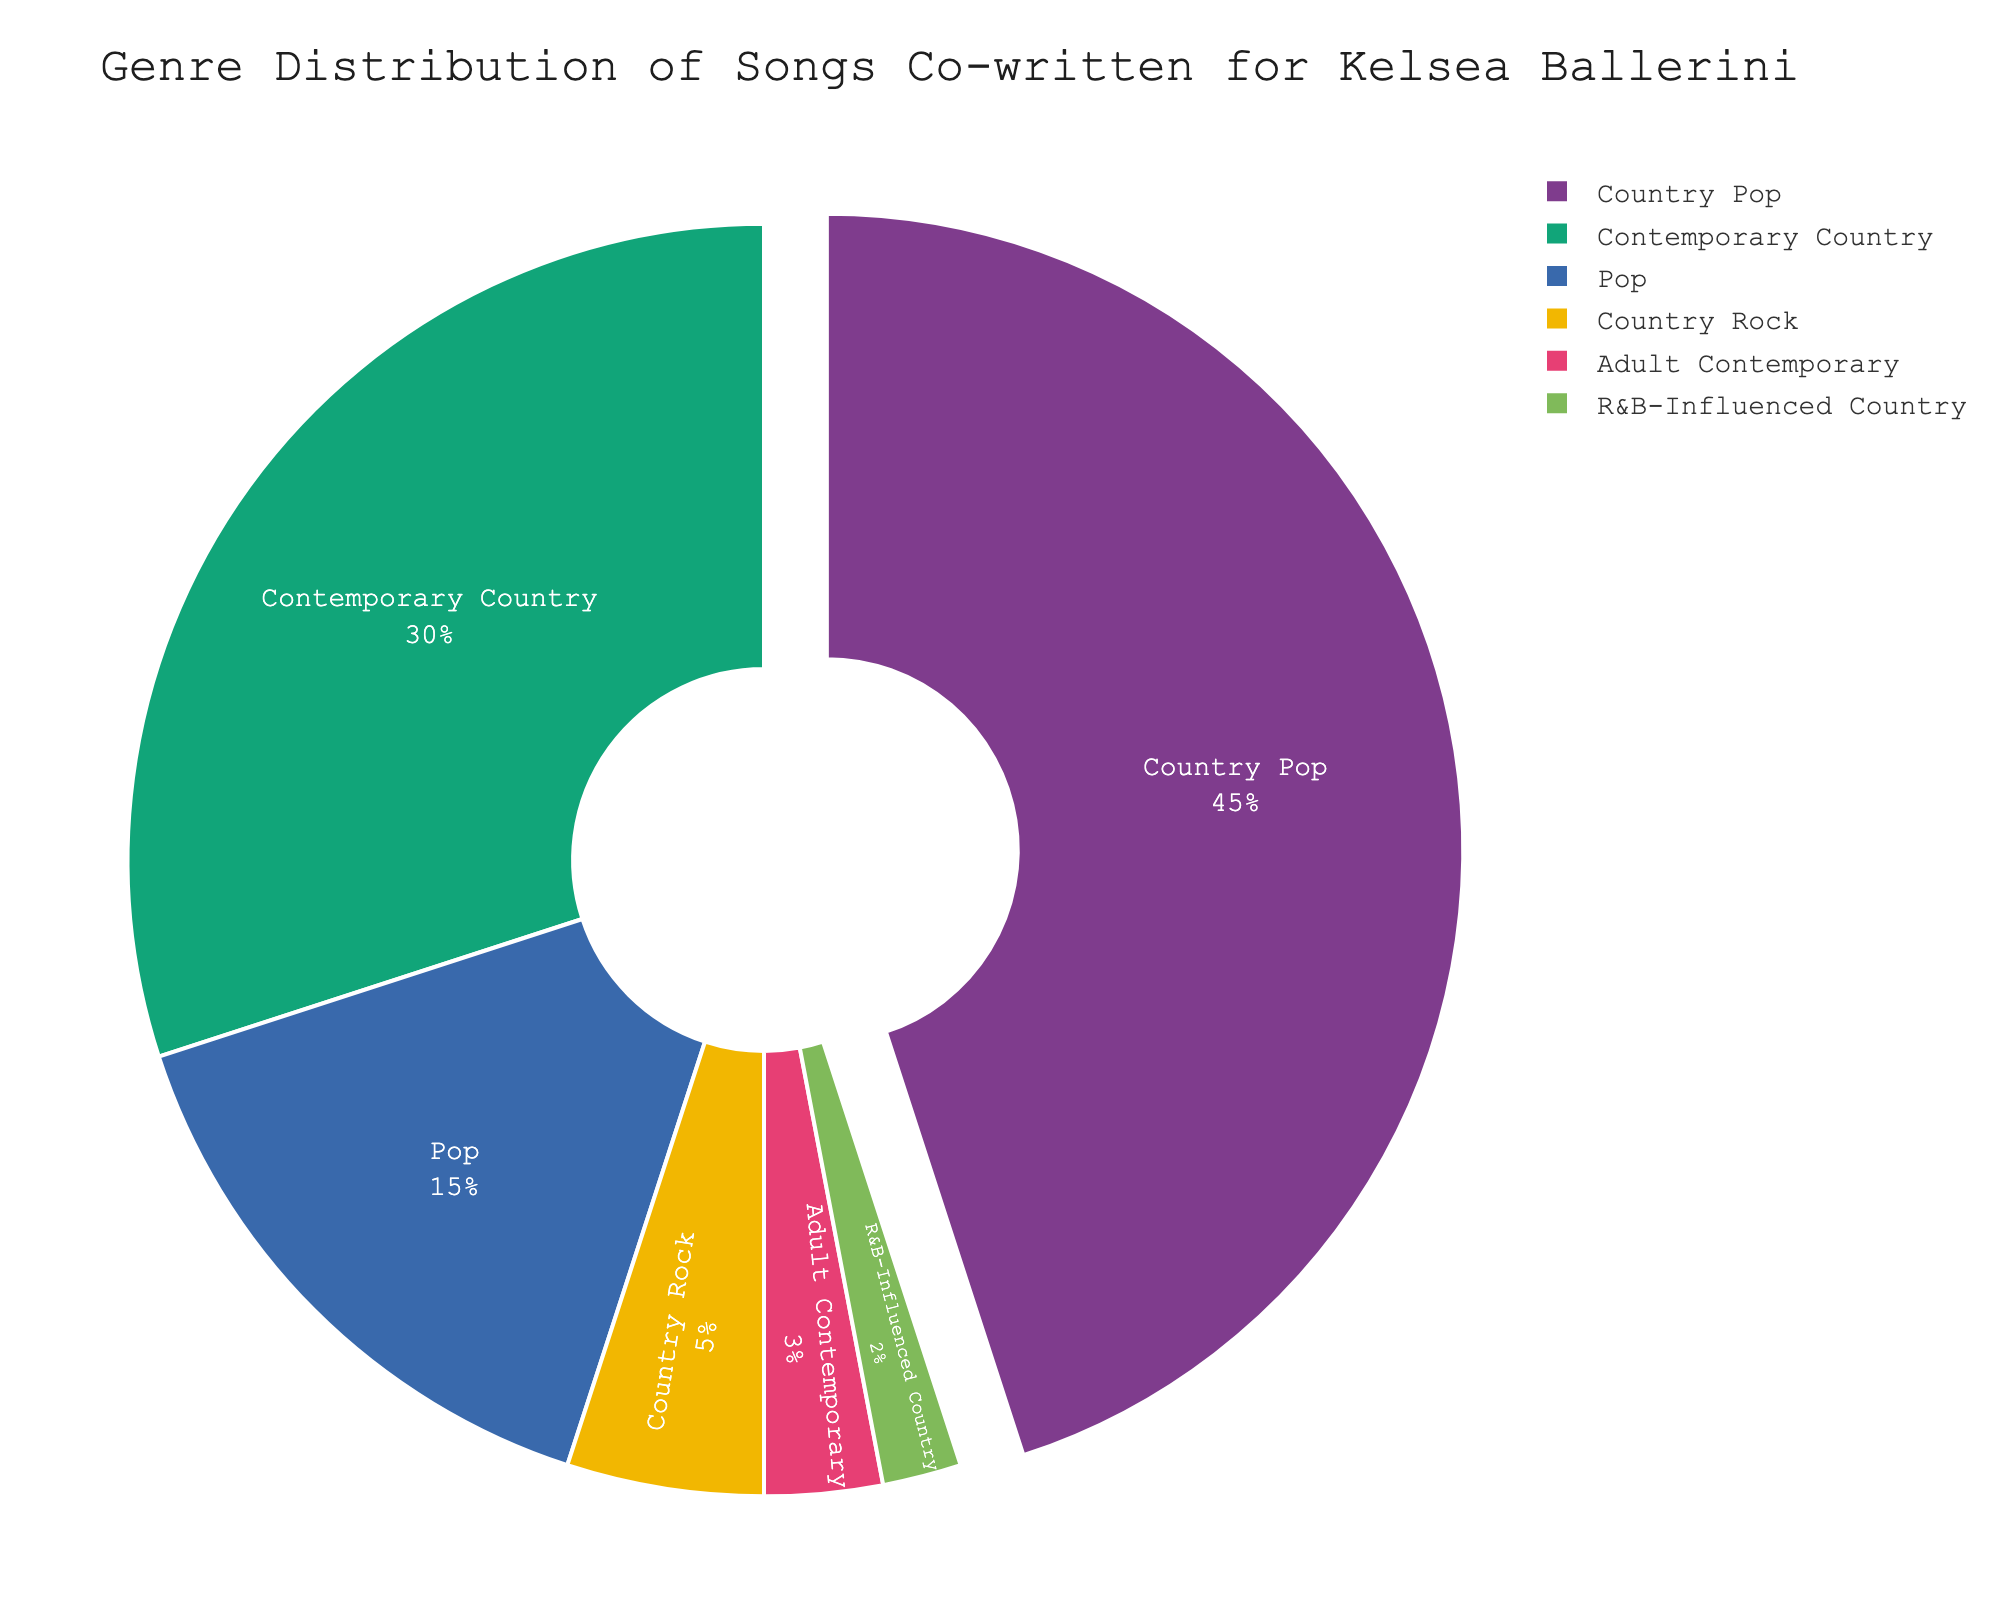What percentage of songs fall under the genre "Country Pop"? The slice labeled "Country Pop" is shown on the chart with a percentage.
Answer: 45% How many genres have a percentage lower than 10%? The genres "Country Rock", "Adult Contemporary", and "R&B-Influenced Country" each have a percentage below 10%. Adding these gives three genres.
Answer: 3 What is the combined percentage of "Contemporary Country" and "Pop"? Refer to the chart for the percentages: Contemporary Country (30%) and Pop (15%). Adding these: 30 + 15 = 45
Answer: 45% Which genre has the smallest percentage? The chart shows that "R&B-Influenced Country" has the smallest slice.
Answer: R&B-Influenced Country How much larger is the percentage for "Country Pop" than "Country Rock"? Country Pop is 45% and Country Rock is 5%. Subtracting these: 45 - 5 = 40
Answer: 40% What is the percentage difference between "Adult Contemporary" and "Pop"? Adult Contemporary is 3% and Pop is 15%. Subtracting these: 15 - 3 = 12
Answer: 12% Other than "Country Pop", which genre has the highest percentage? "Contemporary Country" has the second-largest slice after "Country Pop".
Answer: Contemporary Country If a new genre is added with a 5% share, what will the new total percentage be for genres with 5% or less? Currently, "Country Rock" (5%), "Adult Contemporary" (3%), and "R&B-Influenced Country" (2%) have a combined total of 5 + 3 + 2 = 10%. Adding another 5% results in 10 + 5 = 15%.
Answer: 15% What is the visual difference between the slices representing "Pop" and "Country Rock" genres? By visual observation, the "Pop" slice is substantially larger than the "Country Rock" slice, as shown in the chart.
Answer: Pop slice is larger If "Country Pop" were to decrease by 10%, what would its new percentage be? Subtracting 10% from the current "Country Pop" percentage of 45%, the new percentage is 45 - 10 = 35%
Answer: 35% 